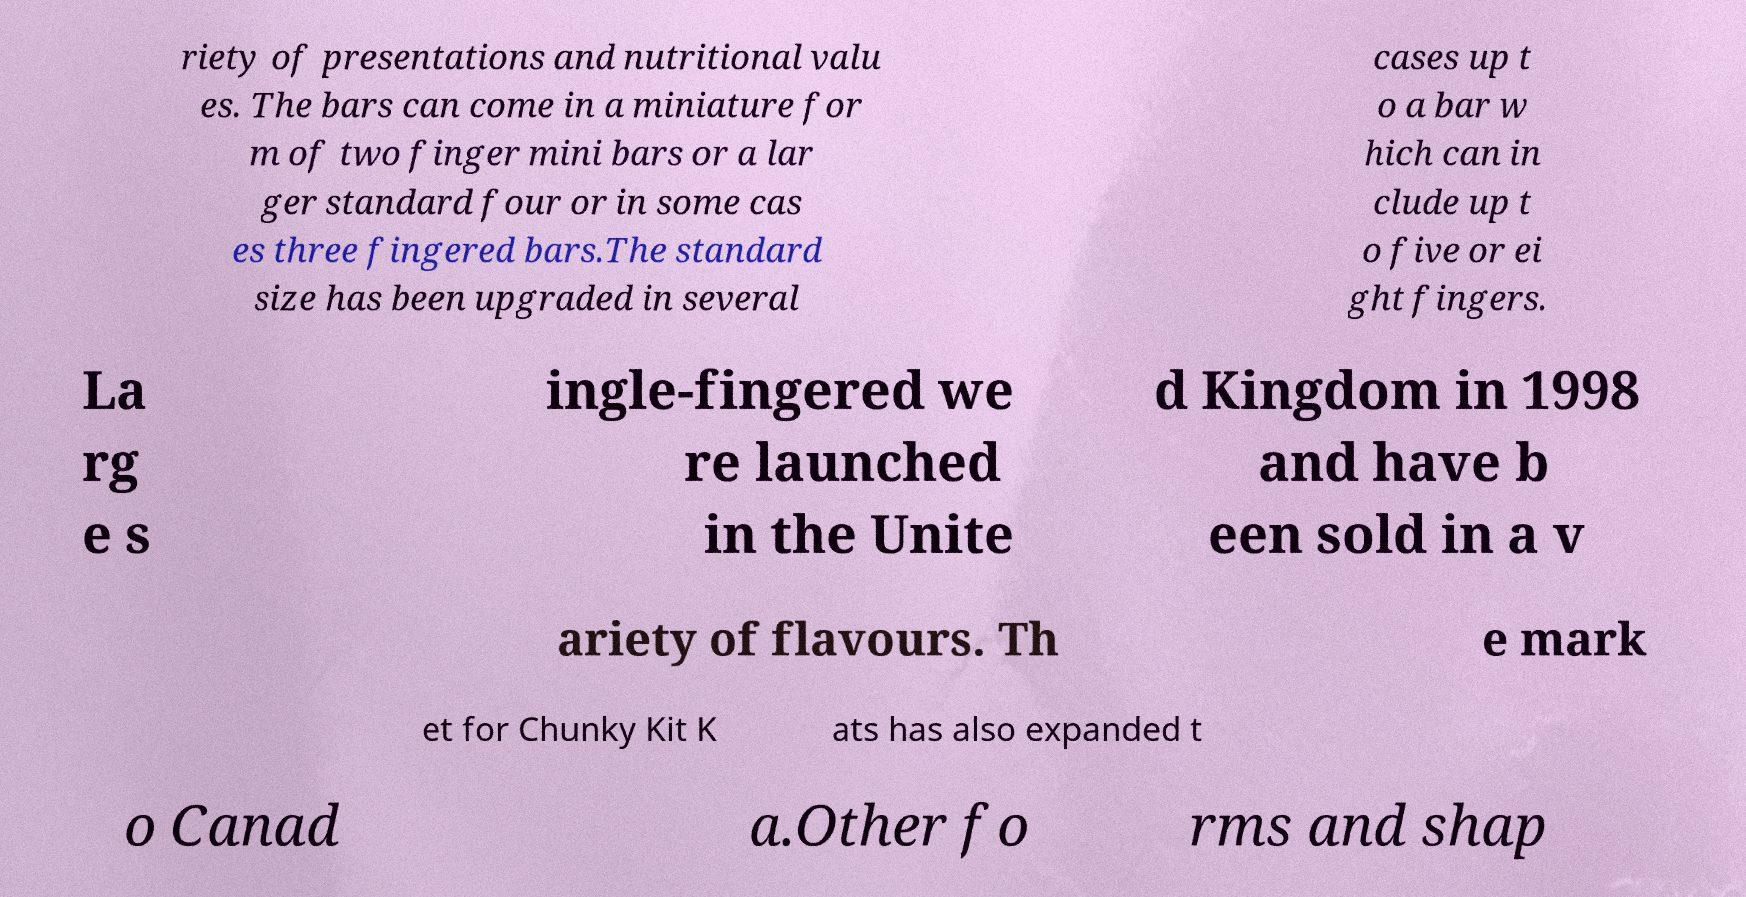I need the written content from this picture converted into text. Can you do that? riety of presentations and nutritional valu es. The bars can come in a miniature for m of two finger mini bars or a lar ger standard four or in some cas es three fingered bars.The standard size has been upgraded in several cases up t o a bar w hich can in clude up t o five or ei ght fingers. La rg e s ingle-fingered we re launched in the Unite d Kingdom in 1998 and have b een sold in a v ariety of flavours. Th e mark et for Chunky Kit K ats has also expanded t o Canad a.Other fo rms and shap 